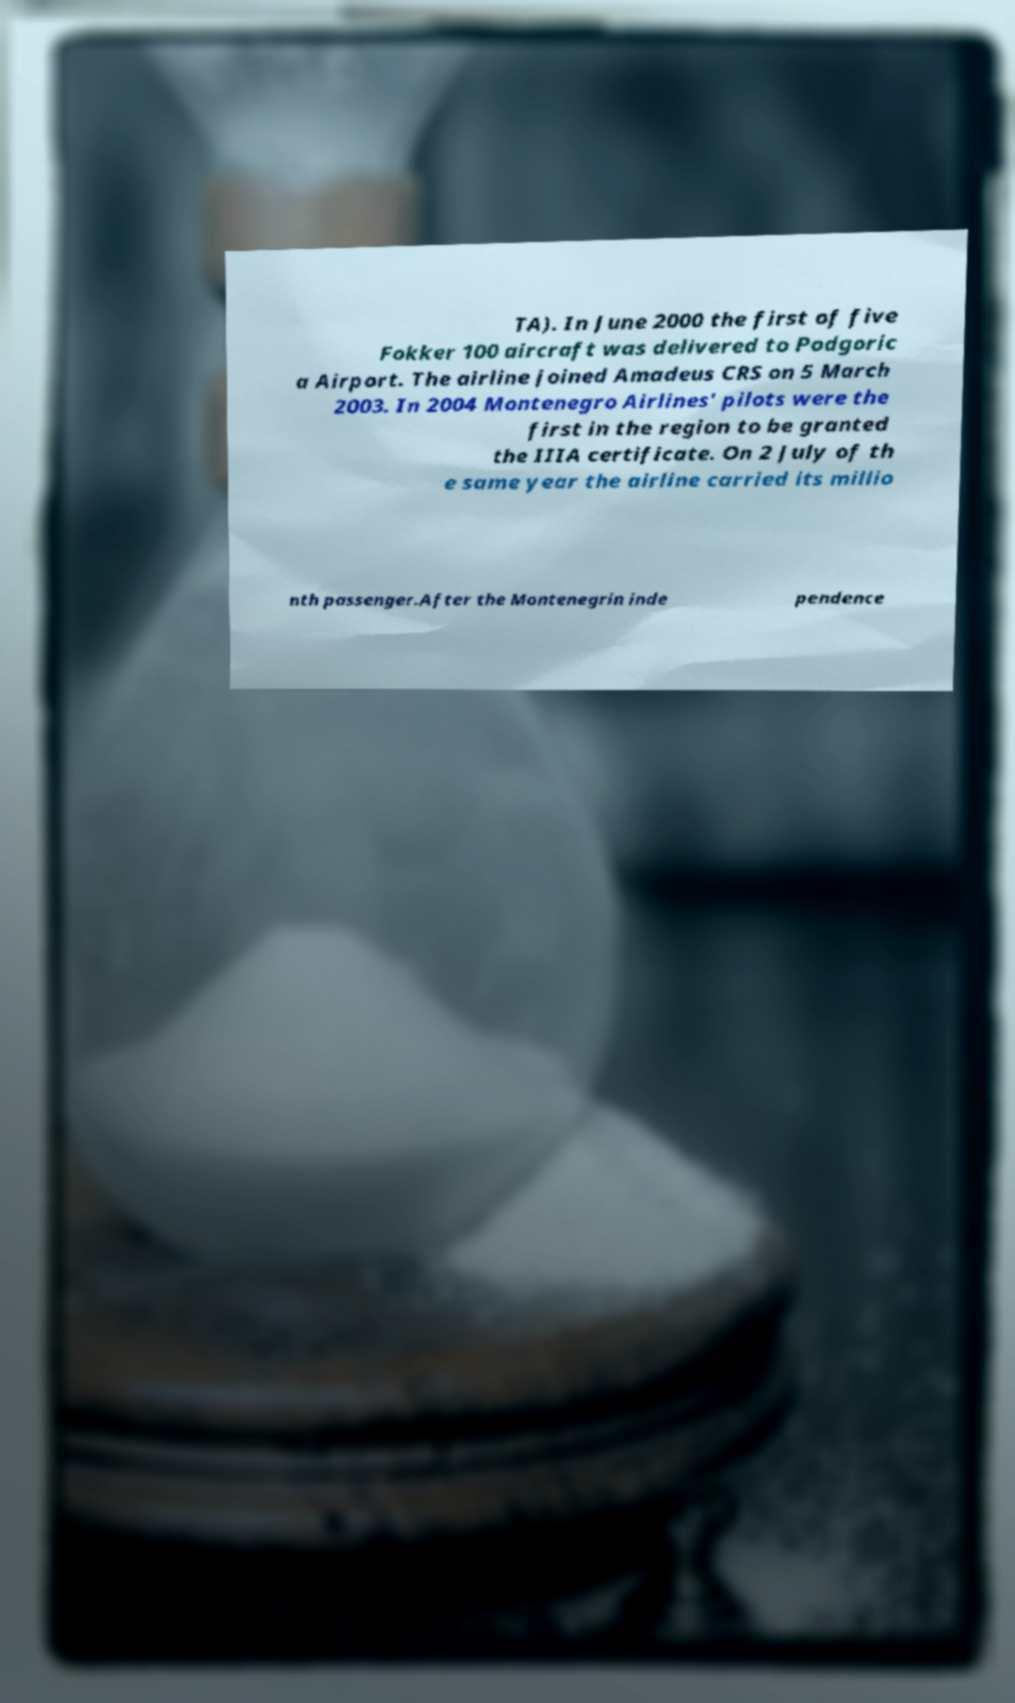Can you accurately transcribe the text from the provided image for me? TA). In June 2000 the first of five Fokker 100 aircraft was delivered to Podgoric a Airport. The airline joined Amadeus CRS on 5 March 2003. In 2004 Montenegro Airlines' pilots were the first in the region to be granted the IIIA certificate. On 2 July of th e same year the airline carried its millio nth passenger.After the Montenegrin inde pendence 